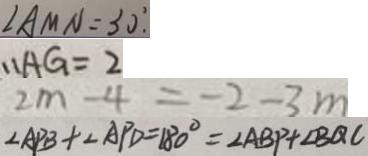Convert formula to latex. <formula><loc_0><loc_0><loc_500><loc_500>\angle A M N = 3 0 ^ { \circ } . 
 \therefore A G = 2 
 2 m - 4 = - 2 - 3 m 
 \angle A P B + \angle A P D = 1 8 0 ^ { \circ } = \angle A B P + \angle B Q C</formula> 